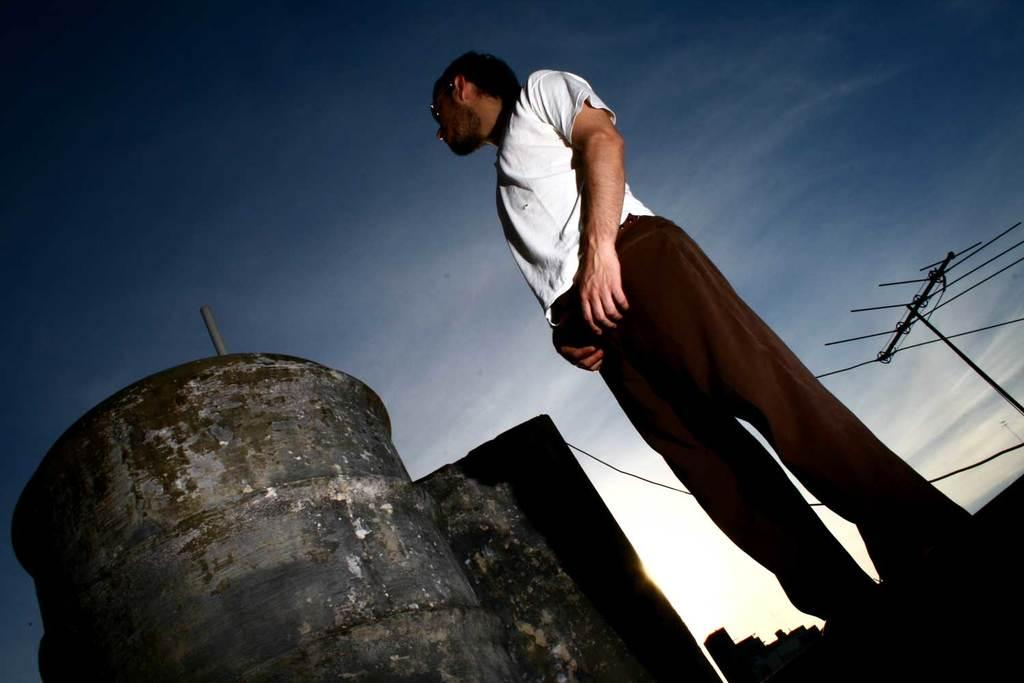What is the main subject of the image? There is a man standing in the image. What is the man looking at? The man is looking at a big iron container. How would you describe the sky in the image? The sky is dark in the image. Can you identify any other objects in the image? There is an antenna on the right side of the image. What type of sweater is the man wearing in the image? There is no sweater visible in the image; the man is not wearing any clothing. Can you tell me how many drawers are present in the image? There are no drawers present in the image. 